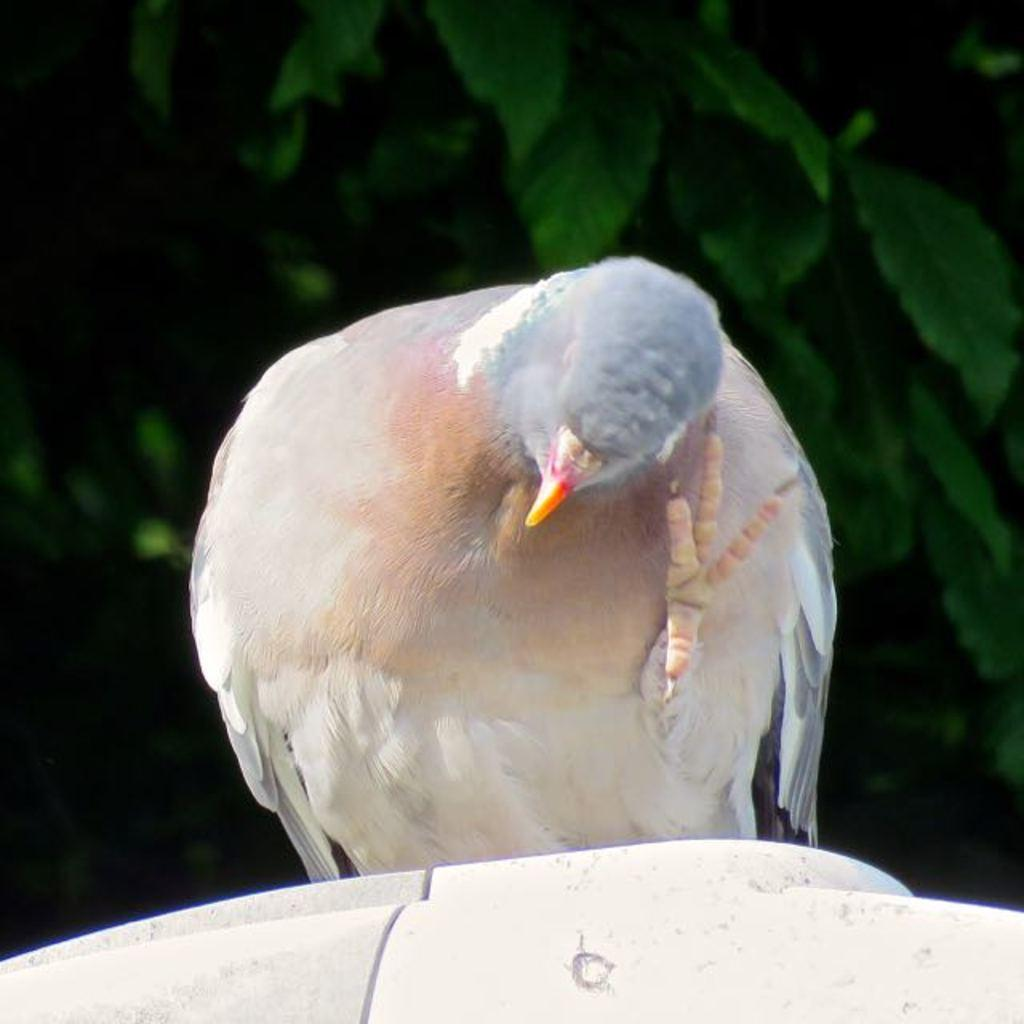What type of animal is present in the image? There is a bird in the image. What colors can be seen on the bird? The bird is in ash and brown color. What is the bird standing on in the image? The bird is on a white surface. What can be seen in the background of the image? There are trees in the background of the image. What type of button can be seen on the bird's nose in the image? There is no button or nose present on the bird in the image; it is a bird with natural features. 